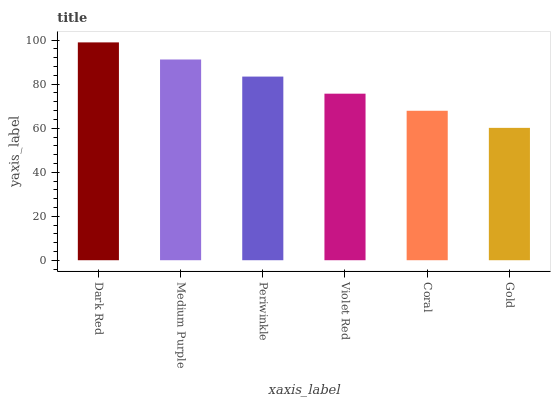Is Gold the minimum?
Answer yes or no. Yes. Is Dark Red the maximum?
Answer yes or no. Yes. Is Medium Purple the minimum?
Answer yes or no. No. Is Medium Purple the maximum?
Answer yes or no. No. Is Dark Red greater than Medium Purple?
Answer yes or no. Yes. Is Medium Purple less than Dark Red?
Answer yes or no. Yes. Is Medium Purple greater than Dark Red?
Answer yes or no. No. Is Dark Red less than Medium Purple?
Answer yes or no. No. Is Periwinkle the high median?
Answer yes or no. Yes. Is Violet Red the low median?
Answer yes or no. Yes. Is Medium Purple the high median?
Answer yes or no. No. Is Gold the low median?
Answer yes or no. No. 